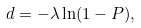Convert formula to latex. <formula><loc_0><loc_0><loc_500><loc_500>d = - \lambda \ln ( 1 - P ) ,</formula> 